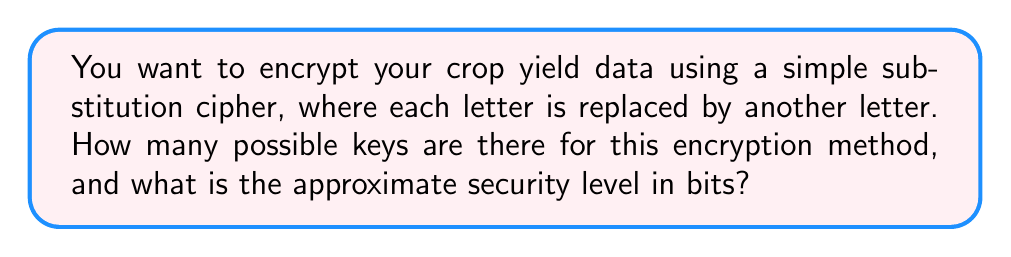Provide a solution to this math problem. Let's approach this step-by-step:

1) In a simple substitution cipher, each letter of the alphabet is replaced by another letter. This means we're essentially creating a permutation of the 26 letters in the English alphabet.

2) The number of possible permutations of 26 items is given by the factorial of 26, which we write as 26!

3) To calculate 26!:
   $$26! = 26 \times 25 \times 24 \times ... \times 3 \times 2 \times 1$$

4) This is a very large number: 
   $$26! = 403,291,461,126,605,635,584,000,000$$

5) To convert this to a security level in bits, we need to find the log base 2 of this number:
   $$\log_2(26!) \approx 88.4$$

6) Rounding down to be conservative, we can say the security level is 88 bits.

7) However, it's important to note that while this seems like a high security level, simple substitution ciphers are actually quite weak because they're vulnerable to frequency analysis. In practice, they can often be broken much more easily than this security level suggests.
Answer: 88 bits 